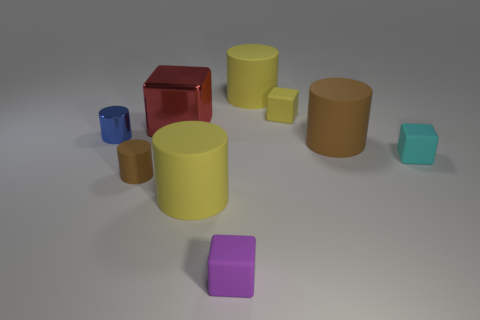Subtract all blue cylinders. How many cylinders are left? 4 Subtract all blue cylinders. How many cylinders are left? 4 Subtract all purple cylinders. Subtract all cyan cubes. How many cylinders are left? 5 Add 1 small matte cylinders. How many objects exist? 10 Subtract all cylinders. How many objects are left? 4 Subtract 0 blue cubes. How many objects are left? 9 Subtract all big blue matte balls. Subtract all tiny cubes. How many objects are left? 6 Add 7 blue cylinders. How many blue cylinders are left? 8 Add 9 red metal cylinders. How many red metal cylinders exist? 9 